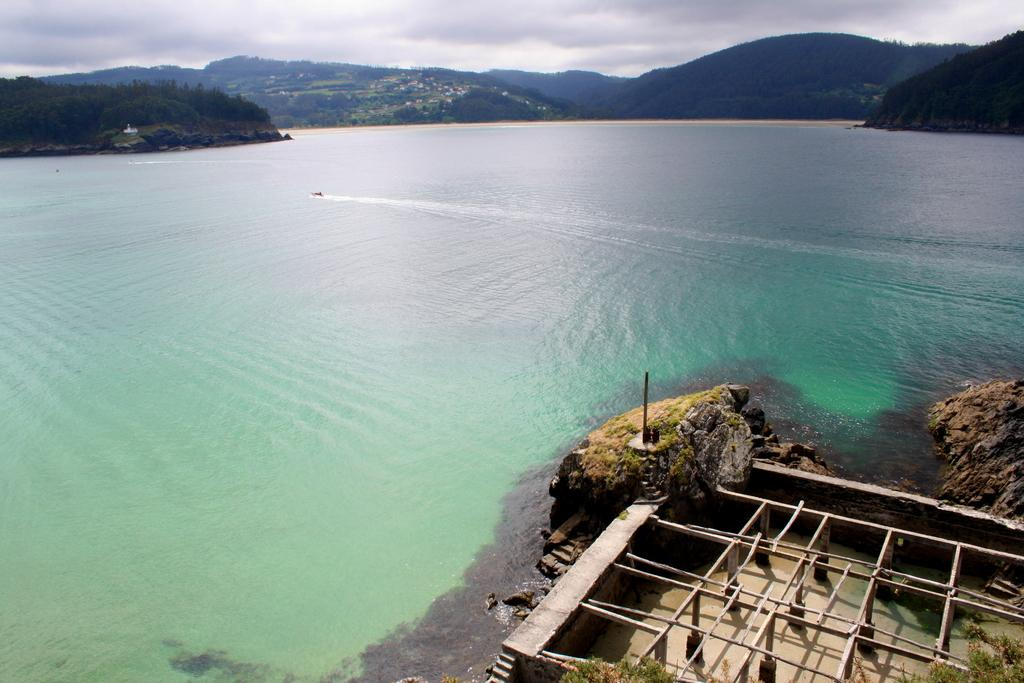What is located at the bottom of the image? There is a construction at the bottom of the image. What can be seen in the middle of the image? The middle of the image contains the sea. What type of natural formation is visible at the back side of the image? There are hills visible at the back side of the image. What is the condition of the sky in the image? The sky is cloudy at the top of the image. Can you tell me how many squares are visible in the image? There are no squares present in the image. Is your aunt visible in the image? There is no reference to an aunt in the image, so it cannot be determined if she is present. 